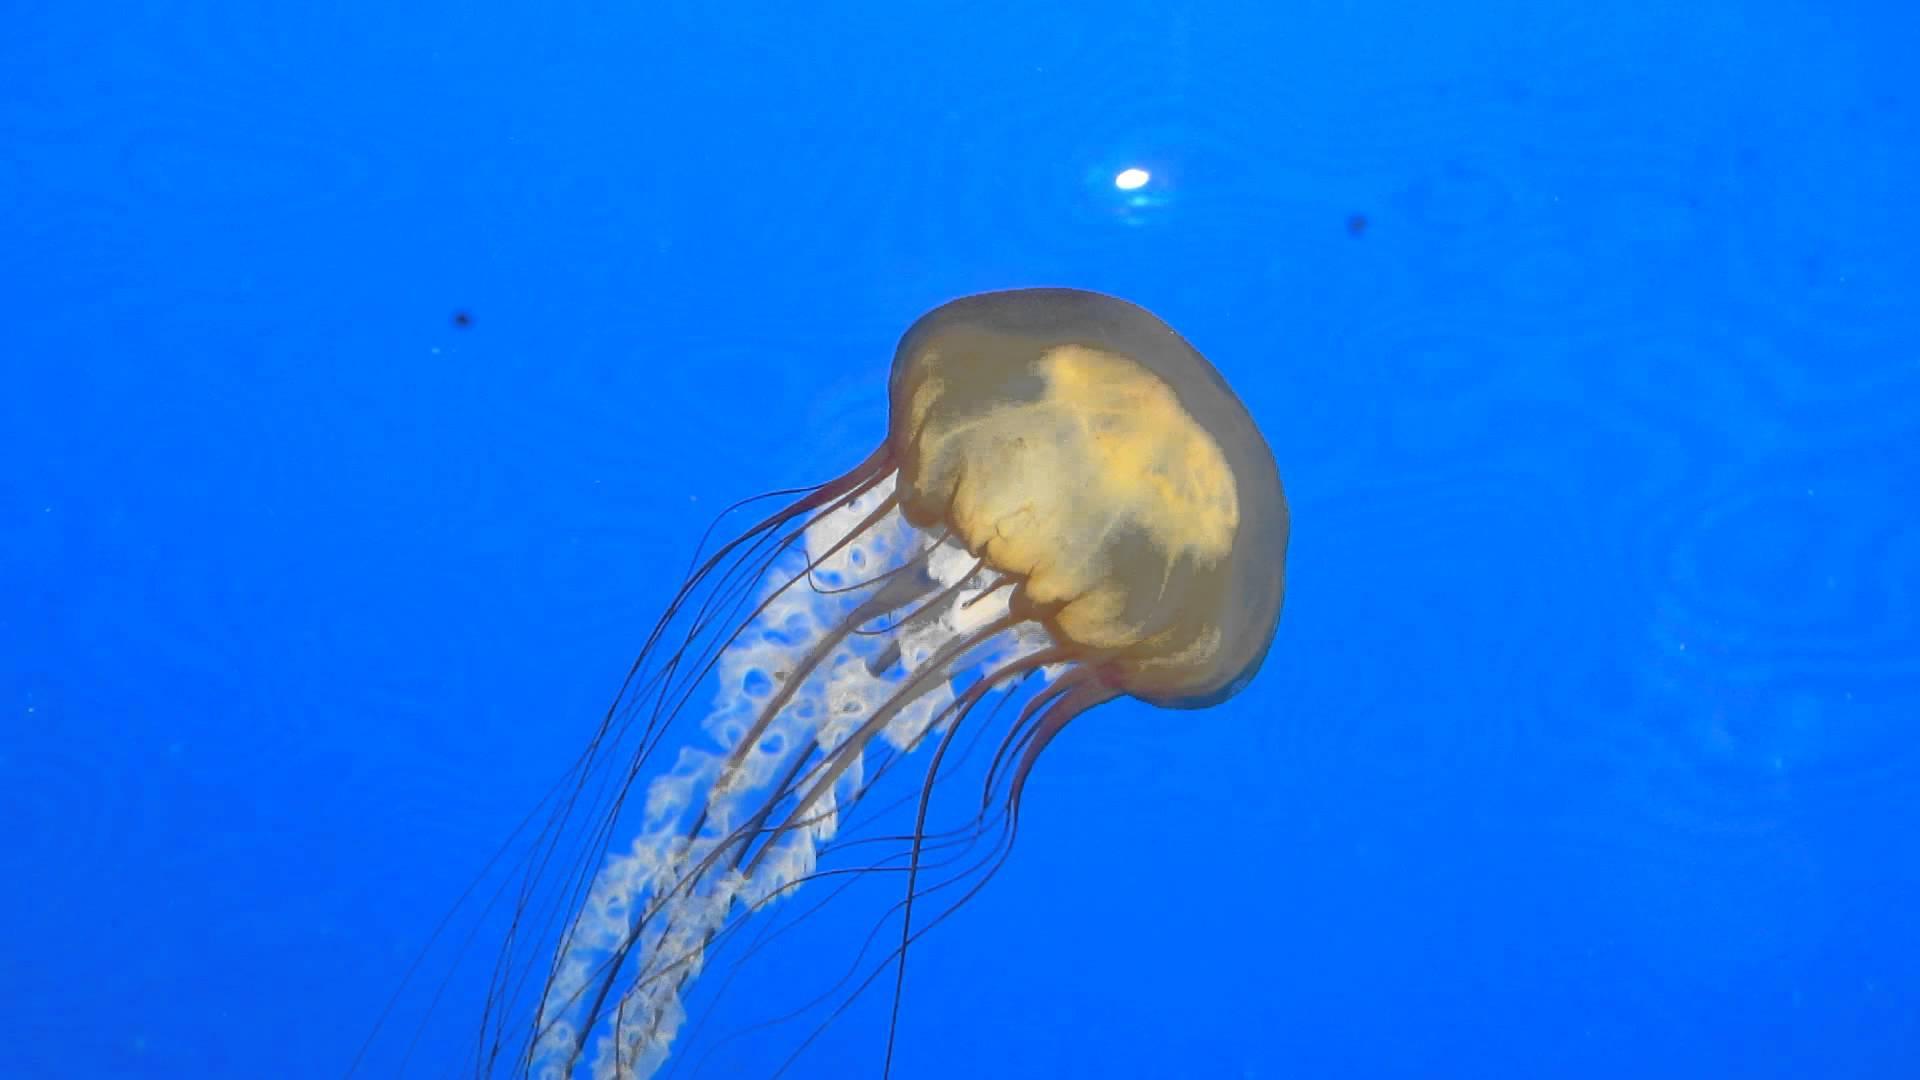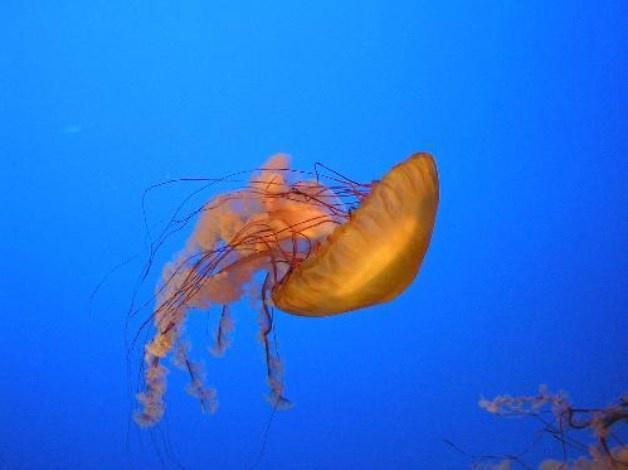The first image is the image on the left, the second image is the image on the right. For the images displayed, is the sentence "The right-hand jellyfish appears tilted down, with its """"cap"""" going  rightward." factually correct? Answer yes or no. Yes. 